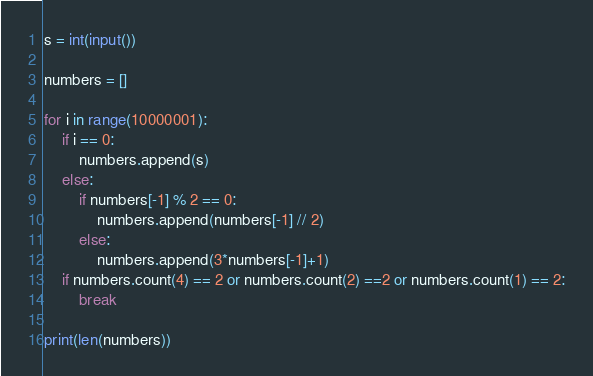<code> <loc_0><loc_0><loc_500><loc_500><_Python_>s = int(input())

numbers = []

for i in range(10000001):
    if i == 0:
        numbers.append(s)
    else:
        if numbers[-1] % 2 == 0:
            numbers.append(numbers[-1] // 2)
        else:
            numbers.append(3*numbers[-1]+1)
    if numbers.count(4) == 2 or numbers.count(2) ==2 or numbers.count(1) == 2:
        break

print(len(numbers))</code> 